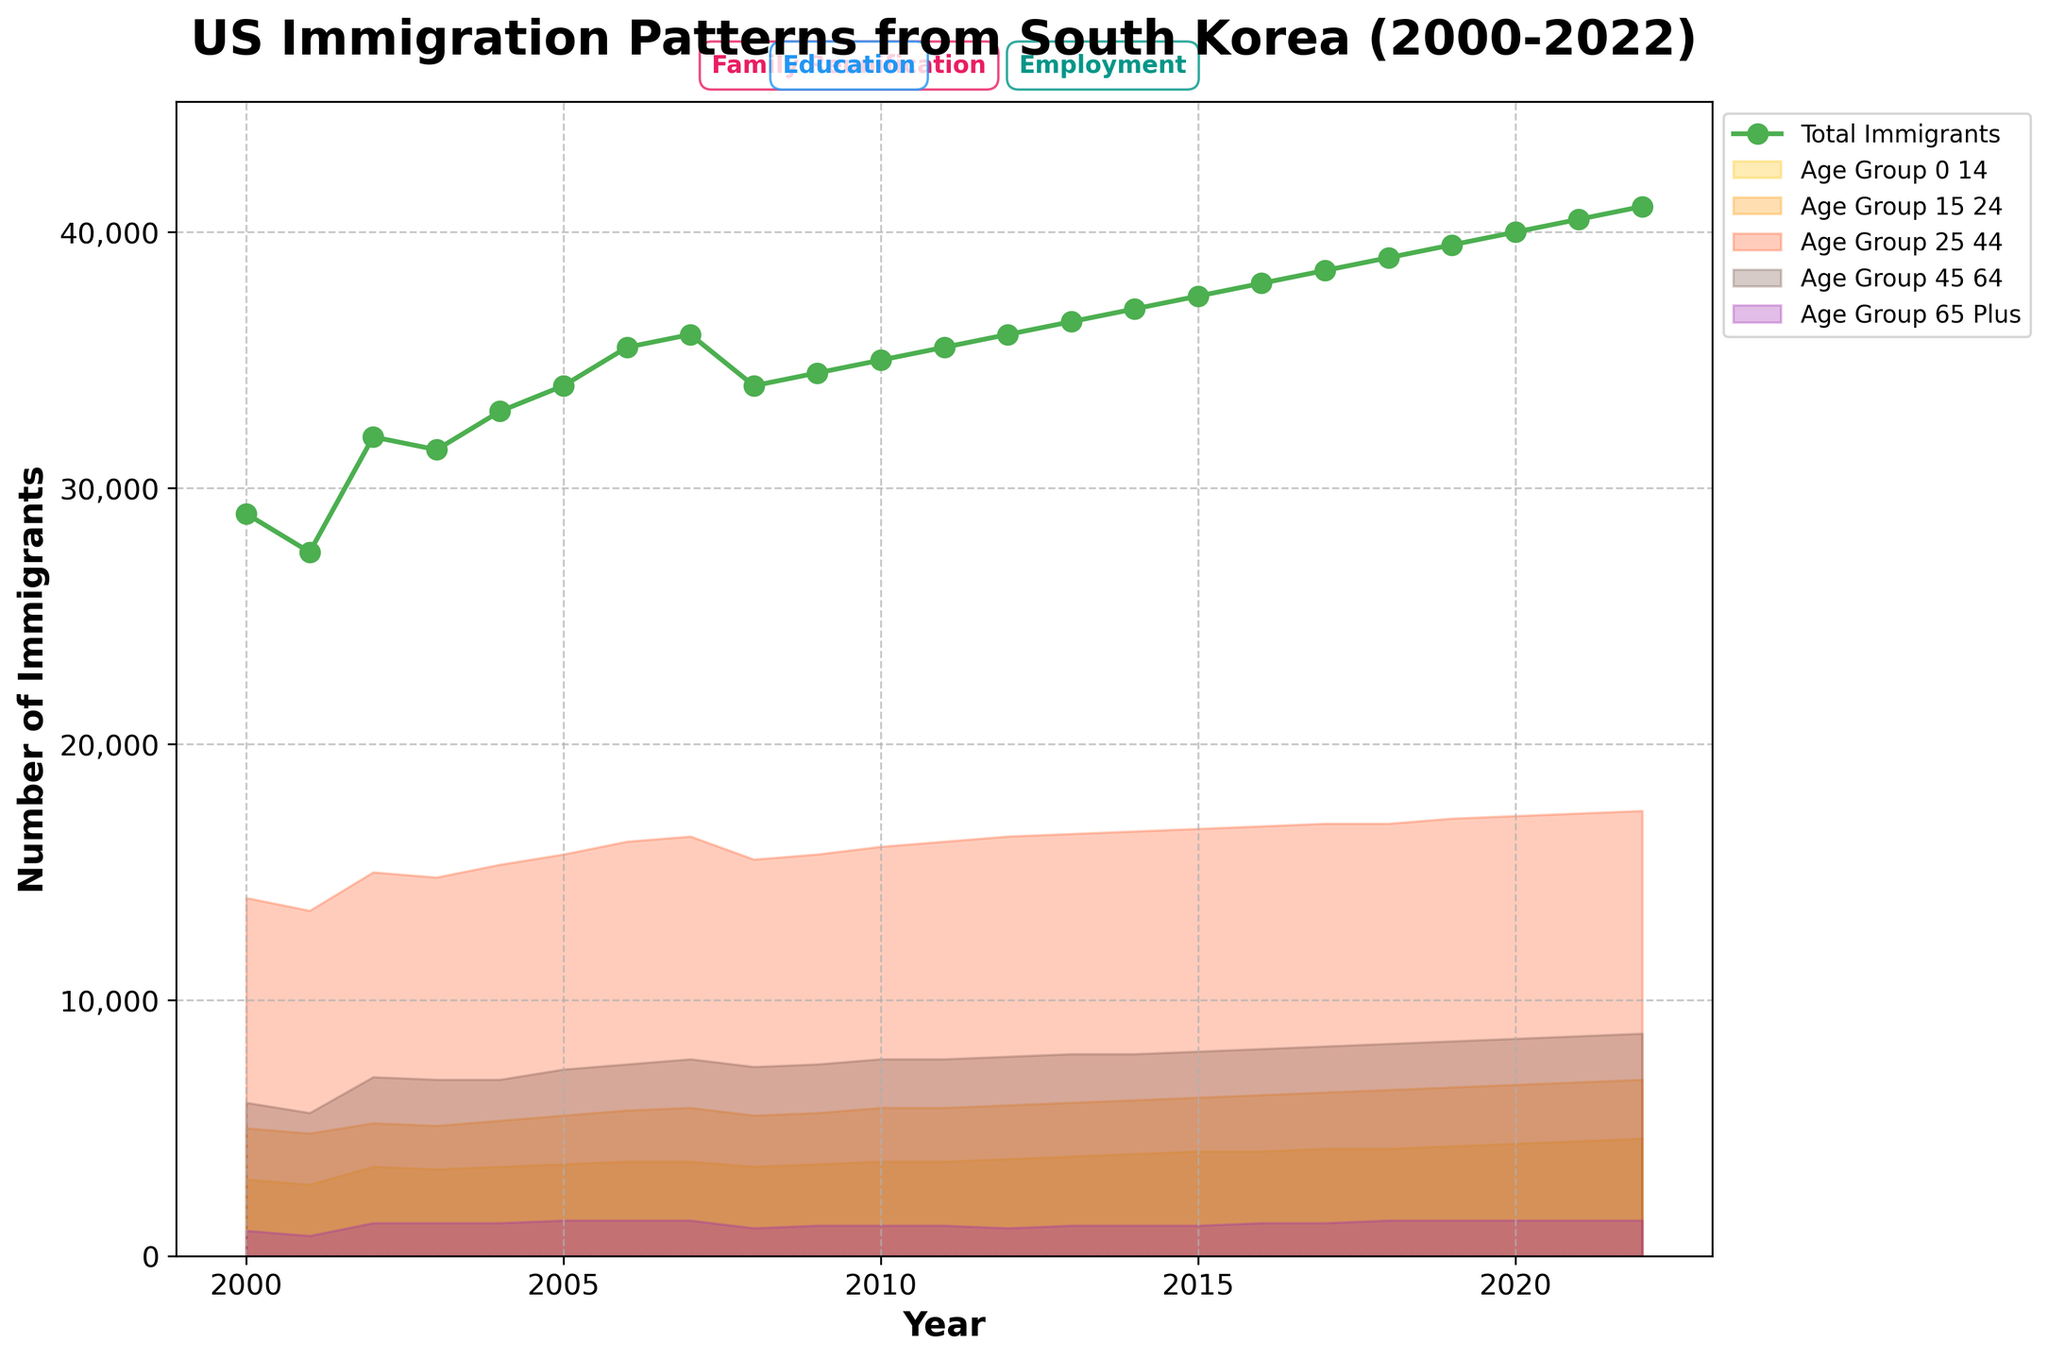What is the title of the figure? Look at the top of the figure where the title is displayed prominently.
Answer: US Immigration Patterns from South Korea (2000-2022) How many age groups are displayed on the plot? Identify the different age group labels used in the legend and the figure.
Answer: 5 In which year did the total number of immigrants peak? Observe the line graph representing the total number of immigrants and identify the year with the highest point.
Answer: 2022 Which color represents the age group "Age Group 0-14"? Check the filling color in the plot and the corresponding color in the legend for "Age Group 0-14."
Answer: Yellow What was the primary motivation for immigration in 2018? Locate the annotation on the plot or the color associated with the primary motivation for the year 2018.
Answer: Family Reunification What are the minimum and maximum total immigrant values over the years? Identify the lowest and highest points on the total immigrants line graph.
Answer: 27,500 and 41,000 Which age group showed the most consistent increase in the number of immigrants? Analyze the trends of different age groups and check for the group with a steady upward trend.
Answer: Age Group 45-64 How does the trend for primary motivations for immigration change over the years? Observe the annotations for primary motivations and notice how they change across different periods.
Answer: Transitioned from Family Reunification to Education, then to Employment Which years had the primary motivation as "Education"? Look at the year labels where "Education" is annotated.
Answer: 2002-2004, 2010-2011, 2016-2017 How does the number of immigrants in the "Age Group 25-44" compare between the years 2005 and 2015? Check the filled area representing "Age Group 25-44" for 2005 and 2015 and compare the values.
Answer: 15,700 in 2005 and 16,700 in 2015 